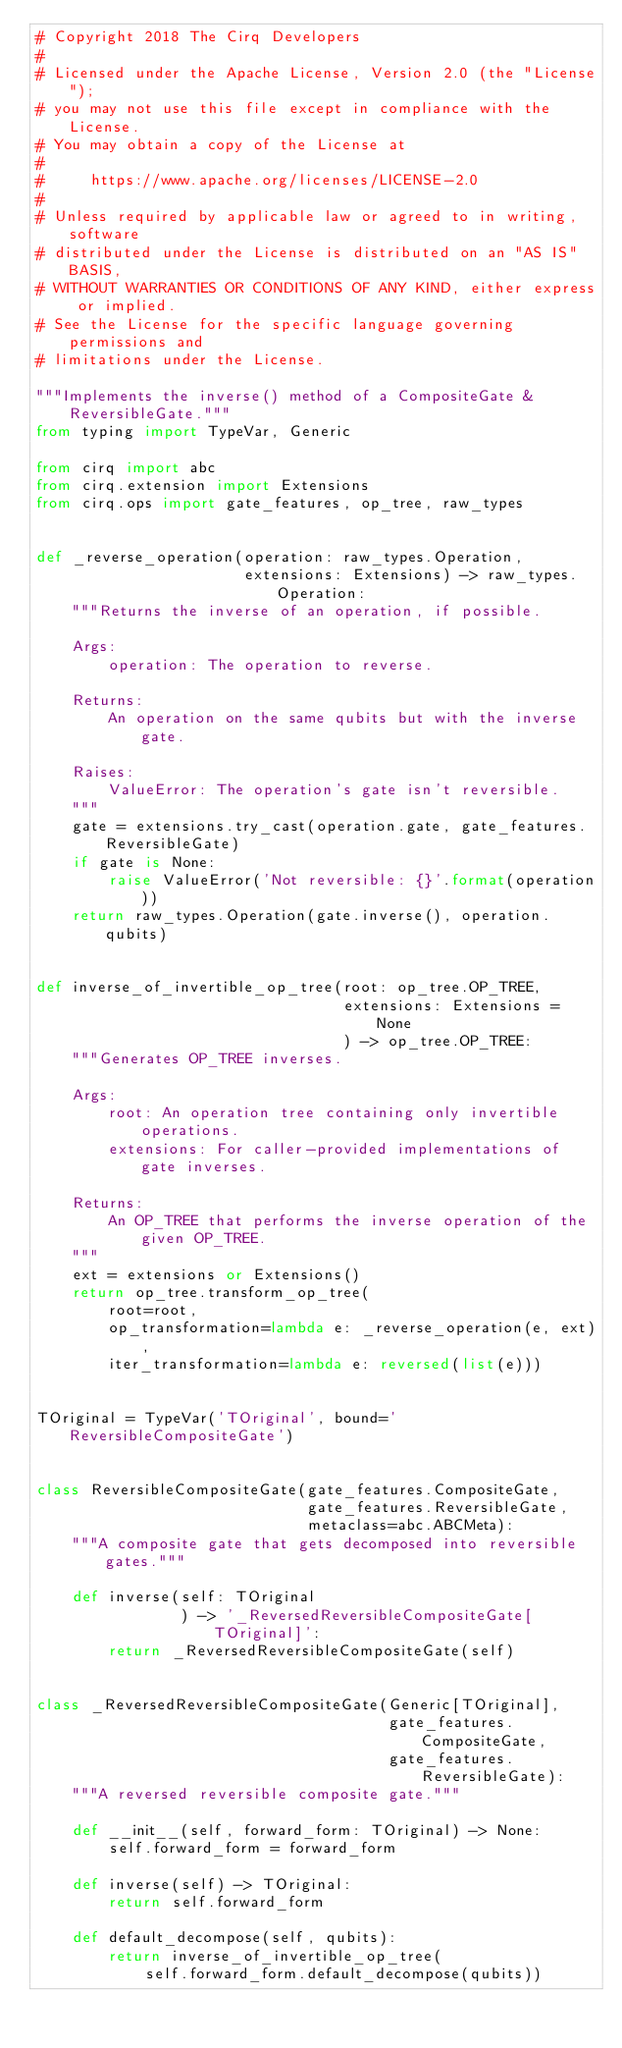<code> <loc_0><loc_0><loc_500><loc_500><_Python_># Copyright 2018 The Cirq Developers
#
# Licensed under the Apache License, Version 2.0 (the "License");
# you may not use this file except in compliance with the License.
# You may obtain a copy of the License at
#
#     https://www.apache.org/licenses/LICENSE-2.0
#
# Unless required by applicable law or agreed to in writing, software
# distributed under the License is distributed on an "AS IS" BASIS,
# WITHOUT WARRANTIES OR CONDITIONS OF ANY KIND, either express or implied.
# See the License for the specific language governing permissions and
# limitations under the License.

"""Implements the inverse() method of a CompositeGate & ReversibleGate."""
from typing import TypeVar, Generic

from cirq import abc
from cirq.extension import Extensions
from cirq.ops import gate_features, op_tree, raw_types


def _reverse_operation(operation: raw_types.Operation,
                       extensions: Extensions) -> raw_types.Operation:
    """Returns the inverse of an operation, if possible.

    Args:
        operation: The operation to reverse.

    Returns:
        An operation on the same qubits but with the inverse gate.

    Raises:
        ValueError: The operation's gate isn't reversible.
    """
    gate = extensions.try_cast(operation.gate, gate_features.ReversibleGate)
    if gate is None:
        raise ValueError('Not reversible: {}'.format(operation))
    return raw_types.Operation(gate.inverse(), operation.qubits)


def inverse_of_invertible_op_tree(root: op_tree.OP_TREE,
                                  extensions: Extensions = None
                                  ) -> op_tree.OP_TREE:
    """Generates OP_TREE inverses.

    Args:
        root: An operation tree containing only invertible operations.
        extensions: For caller-provided implementations of gate inverses.

    Returns:
        An OP_TREE that performs the inverse operation of the given OP_TREE.
    """
    ext = extensions or Extensions()
    return op_tree.transform_op_tree(
        root=root,
        op_transformation=lambda e: _reverse_operation(e, ext),
        iter_transformation=lambda e: reversed(list(e)))


TOriginal = TypeVar('TOriginal', bound='ReversibleCompositeGate')


class ReversibleCompositeGate(gate_features.CompositeGate,
                              gate_features.ReversibleGate,
                              metaclass=abc.ABCMeta):
    """A composite gate that gets decomposed into reversible gates."""

    def inverse(self: TOriginal
                ) -> '_ReversedReversibleCompositeGate[TOriginal]':
        return _ReversedReversibleCompositeGate(self)


class _ReversedReversibleCompositeGate(Generic[TOriginal],
                                       gate_features.CompositeGate,
                                       gate_features.ReversibleGate):
    """A reversed reversible composite gate."""

    def __init__(self, forward_form: TOriginal) -> None:
        self.forward_form = forward_form

    def inverse(self) -> TOriginal:
        return self.forward_form

    def default_decompose(self, qubits):
        return inverse_of_invertible_op_tree(
            self.forward_form.default_decompose(qubits))
</code> 